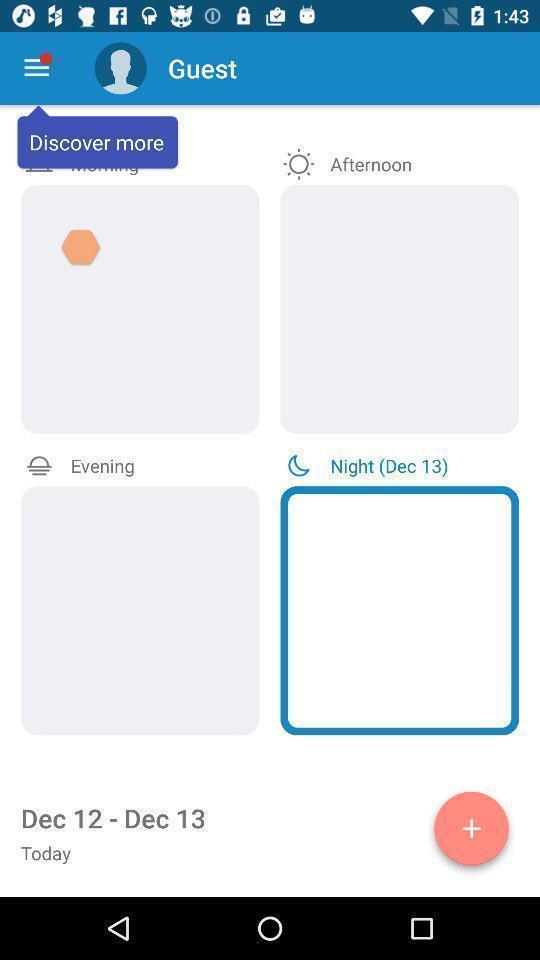Summarize the information in this screenshot. Screen showing page with discover more. 